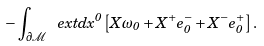Convert formula to latex. <formula><loc_0><loc_0><loc_500><loc_500>- \int _ { \partial { \mathcal { M } } } \ e x t d x ^ { 0 } \left [ X \omega _ { 0 } + X ^ { + } e _ { 0 } ^ { - } + X ^ { - } e _ { 0 } ^ { + } \right ] .</formula> 